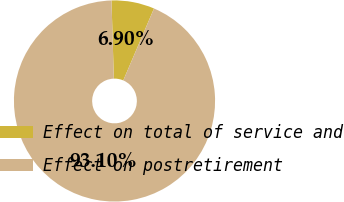Convert chart to OTSL. <chart><loc_0><loc_0><loc_500><loc_500><pie_chart><fcel>Effect on total of service and<fcel>Effect on postretirement<nl><fcel>6.9%<fcel>93.1%<nl></chart> 